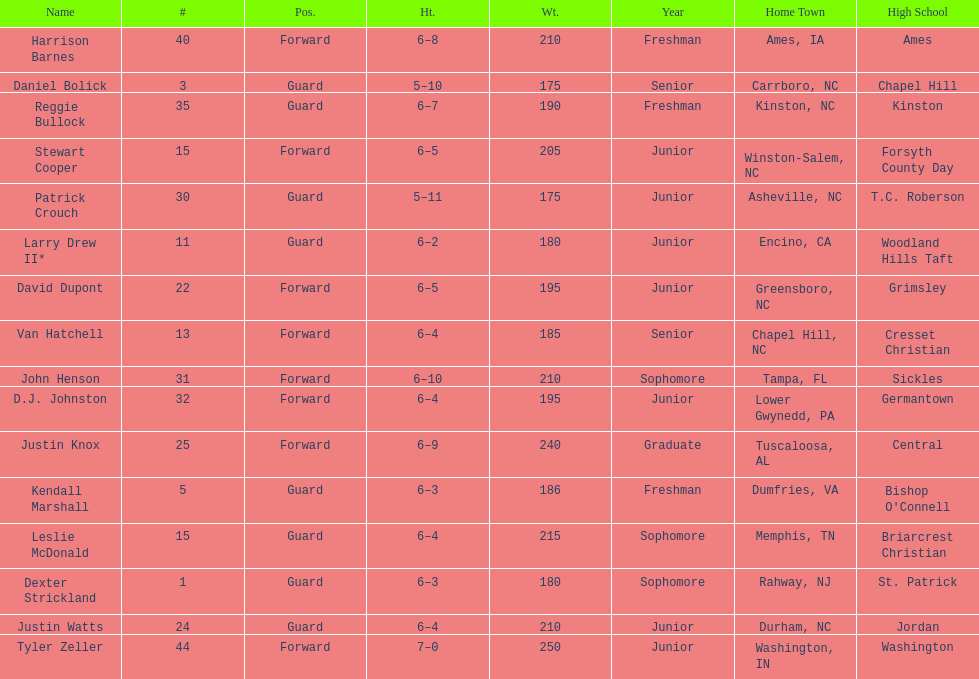What was the number of freshmen on the team? 3. 